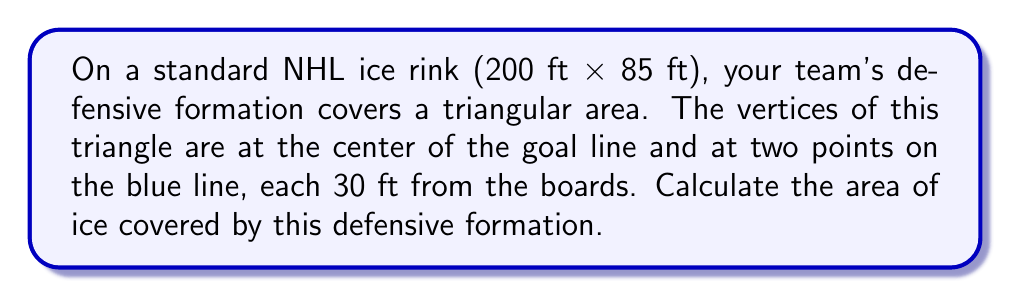Give your solution to this math problem. Let's approach this step-by-step:

1) First, we need to determine the dimensions of our triangle. We know:
   - The width of the rink is 85 ft
   - The distance from each board to the triangle vertex on the blue line is 30 ft
   - The length from the goal line to the blue line is 64 ft (standard NHL rink dimension)

2) The base of our triangle is the distance between the two points on the blue line:
   $$ \text{base} = 85 - (30 \times 2) = 25 \text{ ft} $$

3) The height of our triangle is the distance from the goal line to the blue line:
   $$ \text{height} = 64 \text{ ft} $$

4) The area of a triangle is given by the formula:
   $$ A = \frac{1}{2} \times \text{base} \times \text{height} $$

5) Substituting our values:
   $$ A = \frac{1}{2} \times 25 \times 64 $$

6) Calculating:
   $$ A = \frac{1}{2} \times 1600 = 800 \text{ sq ft} $$

Therefore, the area of ice covered by the defensive formation is 800 square feet.
Answer: 800 sq ft 